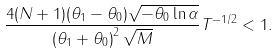<formula> <loc_0><loc_0><loc_500><loc_500>\frac { 4 ( N + 1 ) ( \theta _ { 1 } - \theta _ { 0 } ) \sqrt { - \theta _ { 0 } \ln \alpha } } { \left ( \theta _ { 1 } + \theta _ { 0 } \right ) ^ { 2 } \sqrt { M } } T ^ { - 1 / 2 } < 1 .</formula> 